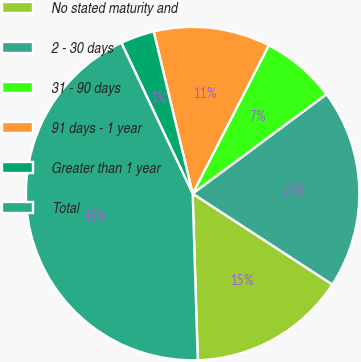<chart> <loc_0><loc_0><loc_500><loc_500><pie_chart><fcel>No stated maturity and<fcel>2 - 30 days<fcel>31 - 90 days<fcel>91 days - 1 year<fcel>Greater than 1 year<fcel>Total<nl><fcel>15.33%<fcel>19.35%<fcel>7.29%<fcel>11.31%<fcel>3.27%<fcel>43.47%<nl></chart> 